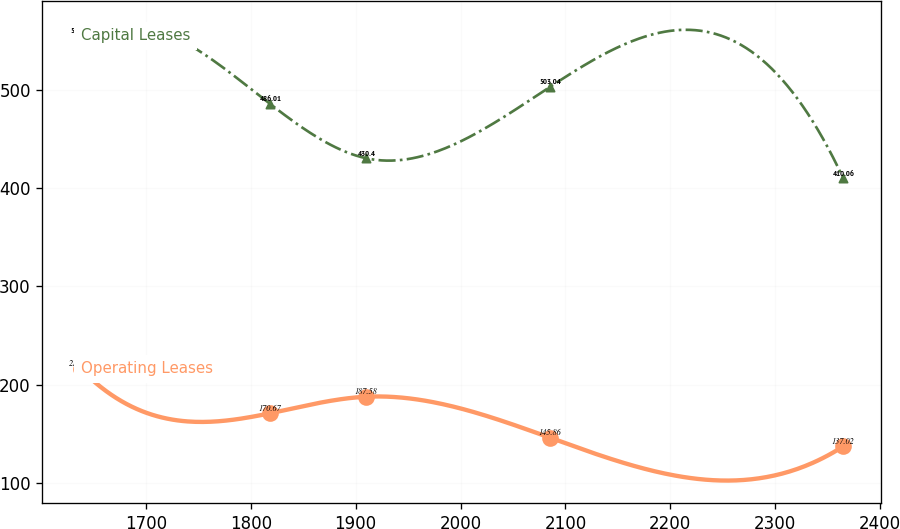Convert chart. <chart><loc_0><loc_0><loc_500><loc_500><line_chart><ecel><fcel>Capital Leases<fcel>Operating Leases<nl><fcel>1637.85<fcel>555.09<fcel>215.99<nl><fcel>1818.19<fcel>486.01<fcel>170.67<nl><fcel>1910.23<fcel>430.4<fcel>187.58<nl><fcel>2085.25<fcel>503.04<fcel>145.86<nl><fcel>2364.83<fcel>410.06<fcel>137.02<nl></chart> 